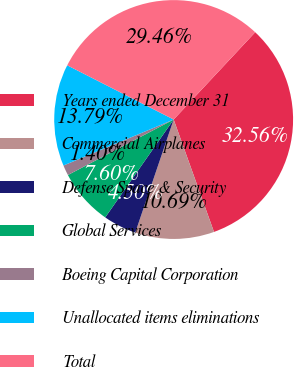Convert chart to OTSL. <chart><loc_0><loc_0><loc_500><loc_500><pie_chart><fcel>Years ended December 31<fcel>Commercial Airplanes<fcel>Defense Space & Security<fcel>Global Services<fcel>Boeing Capital Corporation<fcel>Unallocated items eliminations<fcel>Total<nl><fcel>32.56%<fcel>10.69%<fcel>4.5%<fcel>7.6%<fcel>1.4%<fcel>13.79%<fcel>29.46%<nl></chart> 